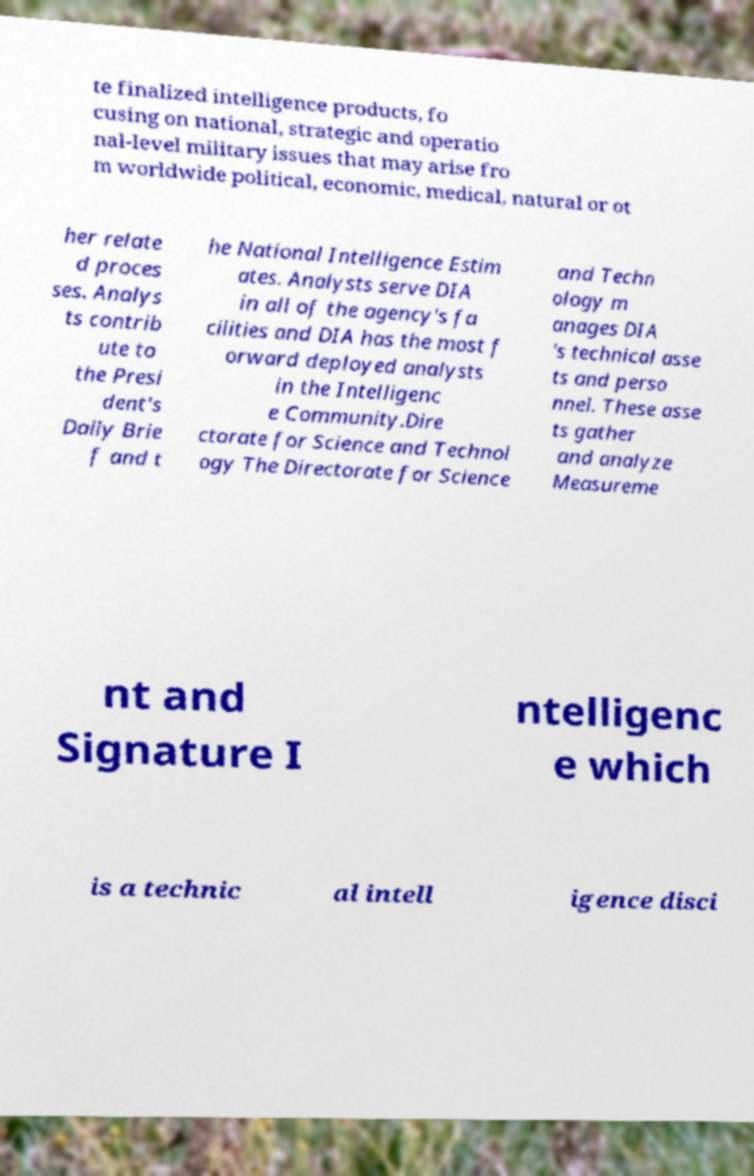Please identify and transcribe the text found in this image. te finalized intelligence products, fo cusing on national, strategic and operatio nal-level military issues that may arise fro m worldwide political, economic, medical, natural or ot her relate d proces ses. Analys ts contrib ute to the Presi dent's Daily Brie f and t he National Intelligence Estim ates. Analysts serve DIA in all of the agency's fa cilities and DIA has the most f orward deployed analysts in the Intelligenc e Community.Dire ctorate for Science and Technol ogy The Directorate for Science and Techn ology m anages DIA 's technical asse ts and perso nnel. These asse ts gather and analyze Measureme nt and Signature I ntelligenc e which is a technic al intell igence disci 